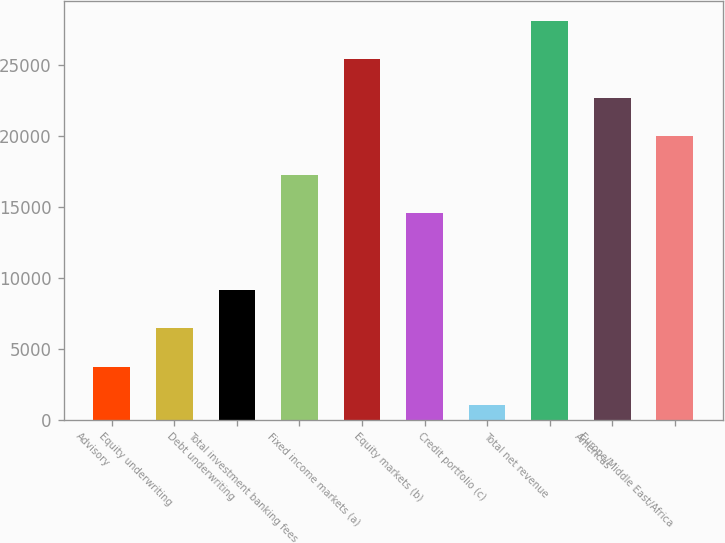<chart> <loc_0><loc_0><loc_500><loc_500><bar_chart><fcel>Advisory<fcel>Equity underwriting<fcel>Debt underwriting<fcel>Total investment banking fees<fcel>Fixed income markets (a)<fcel>Equity markets (b)<fcel>Credit portfolio (c)<fcel>Total net revenue<fcel>Americas<fcel>Europe/Middle East/Africa<nl><fcel>3726.2<fcel>6435.4<fcel>9144.6<fcel>17272.2<fcel>25399.8<fcel>14563<fcel>1017<fcel>28109<fcel>22690.6<fcel>19981.4<nl></chart> 